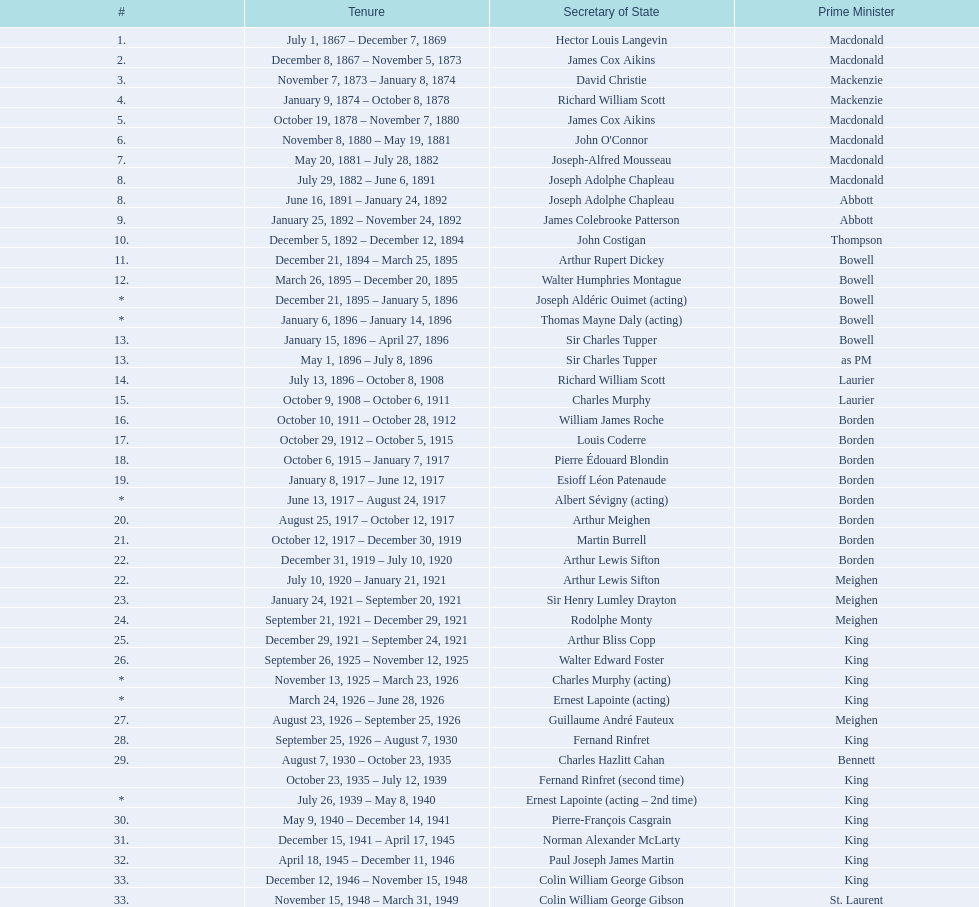Which secretary of state came after jack pkckersgill? Roch Pinard. 